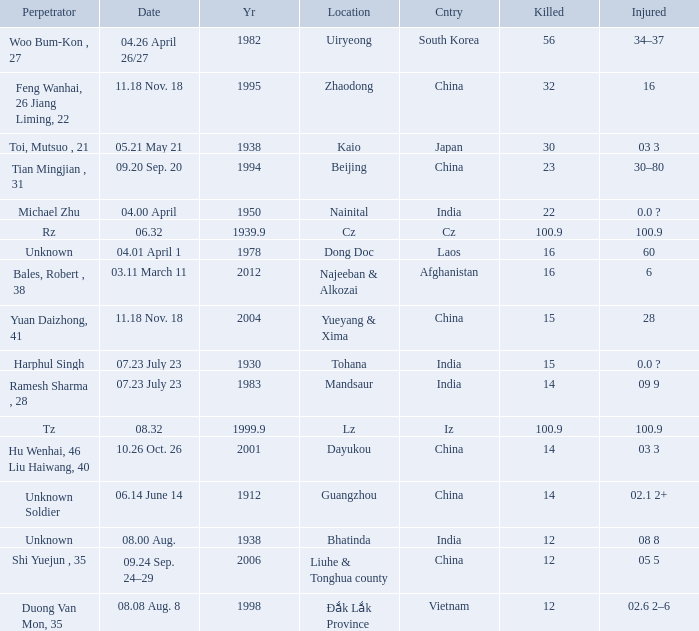What is Injured, when Country is "Afghanistan"? 6.0. 